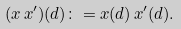Convert formula to latex. <formula><loc_0><loc_0><loc_500><loc_500>( x \, x ^ { \prime } ) ( d ) \colon = x ( d ) \, x ^ { \prime } ( d ) .</formula> 